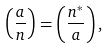Convert formula to latex. <formula><loc_0><loc_0><loc_500><loc_500>\left ( \frac { a } { n } \right ) = \left ( \frac { n ^ { * } } { a } \right ) ,</formula> 